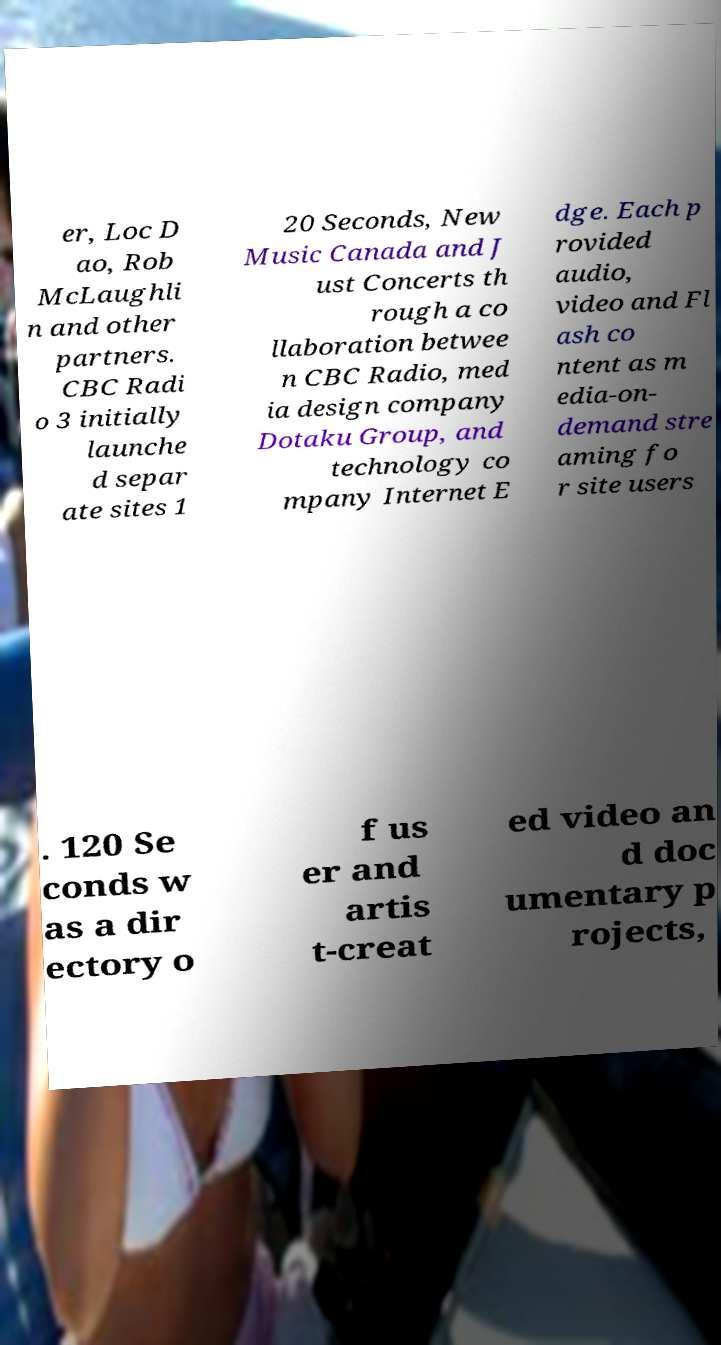Please read and relay the text visible in this image. What does it say? er, Loc D ao, Rob McLaughli n and other partners. CBC Radi o 3 initially launche d separ ate sites 1 20 Seconds, New Music Canada and J ust Concerts th rough a co llaboration betwee n CBC Radio, med ia design company Dotaku Group, and technology co mpany Internet E dge. Each p rovided audio, video and Fl ash co ntent as m edia-on- demand stre aming fo r site users . 120 Se conds w as a dir ectory o f us er and artis t-creat ed video an d doc umentary p rojects, 